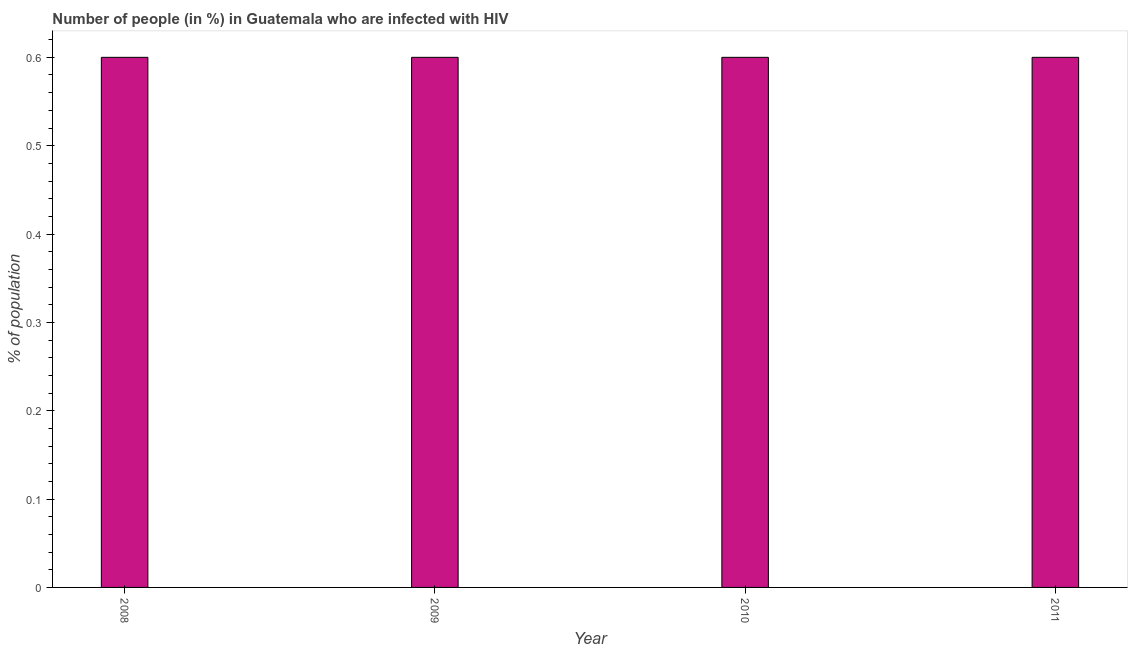Does the graph contain any zero values?
Offer a very short reply. No. Does the graph contain grids?
Give a very brief answer. No. What is the title of the graph?
Your answer should be very brief. Number of people (in %) in Guatemala who are infected with HIV. What is the label or title of the X-axis?
Your answer should be compact. Year. What is the label or title of the Y-axis?
Keep it short and to the point. % of population. Across all years, what is the maximum number of people infected with hiv?
Give a very brief answer. 0.6. In which year was the number of people infected with hiv maximum?
Give a very brief answer. 2008. What is the median number of people infected with hiv?
Provide a succinct answer. 0.6. In how many years, is the number of people infected with hiv greater than 0.46 %?
Your answer should be compact. 4. Do a majority of the years between 2011 and 2010 (inclusive) have number of people infected with hiv greater than 0.4 %?
Make the answer very short. No. Is the difference between the number of people infected with hiv in 2008 and 2010 greater than the difference between any two years?
Give a very brief answer. Yes. What is the difference between the highest and the lowest number of people infected with hiv?
Give a very brief answer. 0. In how many years, is the number of people infected with hiv greater than the average number of people infected with hiv taken over all years?
Ensure brevity in your answer.  0. How many bars are there?
Keep it short and to the point. 4. Are all the bars in the graph horizontal?
Ensure brevity in your answer.  No. Are the values on the major ticks of Y-axis written in scientific E-notation?
Offer a very short reply. No. What is the % of population of 2008?
Make the answer very short. 0.6. What is the % of population of 2010?
Your answer should be compact. 0.6. What is the % of population of 2011?
Provide a succinct answer. 0.6. What is the difference between the % of population in 2008 and 2010?
Give a very brief answer. 0. What is the difference between the % of population in 2008 and 2011?
Your answer should be compact. 0. What is the difference between the % of population in 2009 and 2010?
Give a very brief answer. 0. What is the difference between the % of population in 2009 and 2011?
Provide a succinct answer. 0. What is the difference between the % of population in 2010 and 2011?
Make the answer very short. 0. What is the ratio of the % of population in 2009 to that in 2010?
Your answer should be very brief. 1. What is the ratio of the % of population in 2009 to that in 2011?
Provide a short and direct response. 1. What is the ratio of the % of population in 2010 to that in 2011?
Offer a very short reply. 1. 